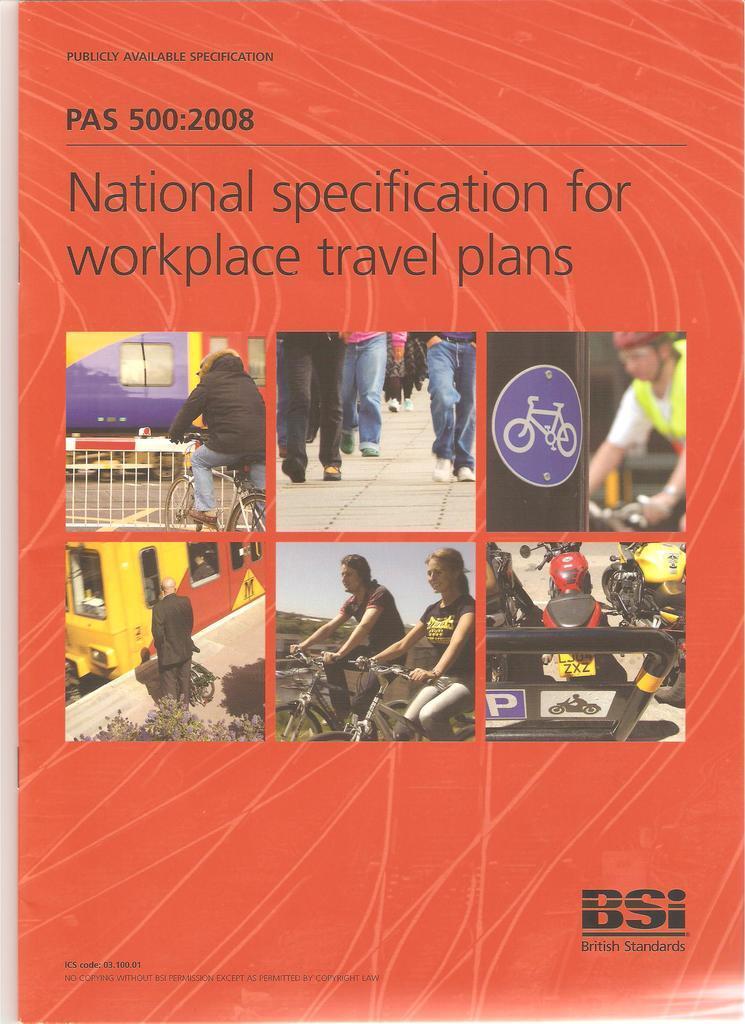Please provide a concise description of this image. In this image I can see a paper and on the paper I can see few persons walking and few persons standing in front of the yellow color bus and some text visible on the paper. 